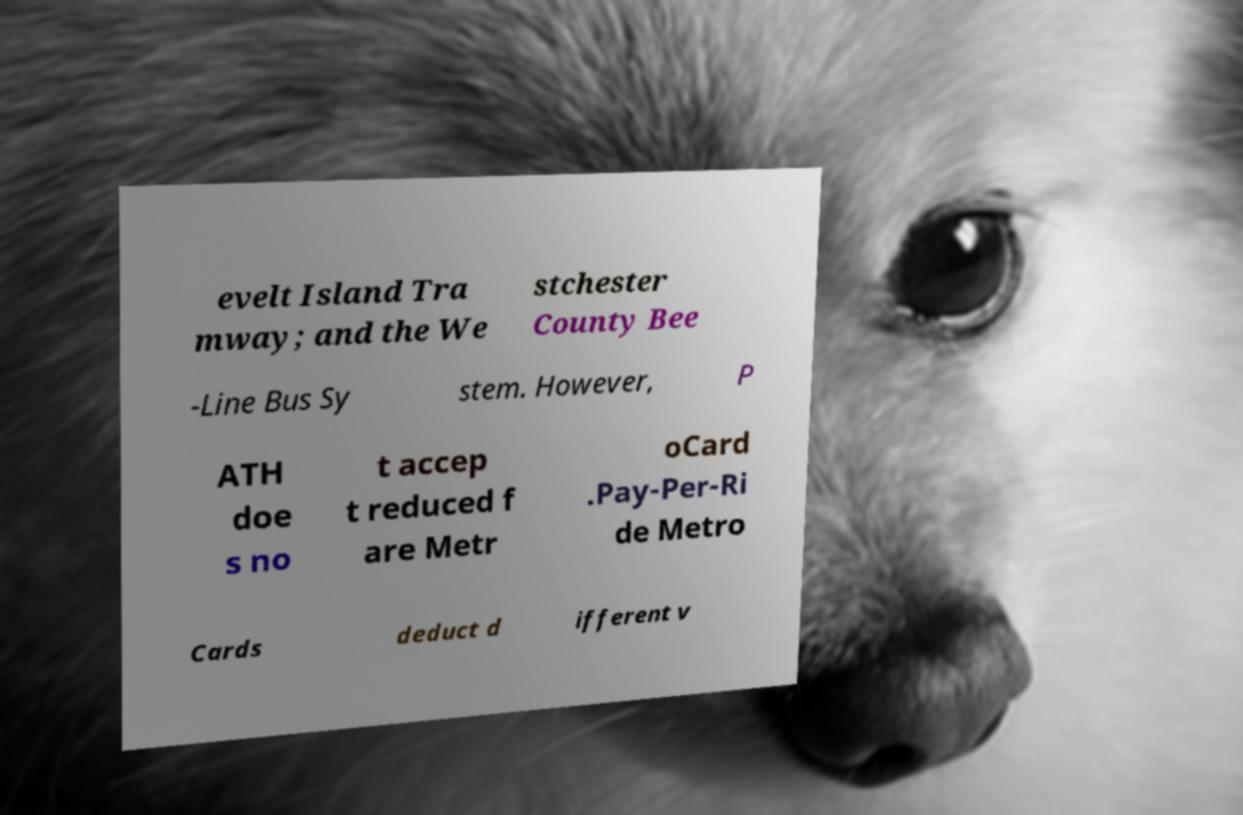Please read and relay the text visible in this image. What does it say? evelt Island Tra mway; and the We stchester County Bee -Line Bus Sy stem. However, P ATH doe s no t accep t reduced f are Metr oCard .Pay-Per-Ri de Metro Cards deduct d ifferent v 